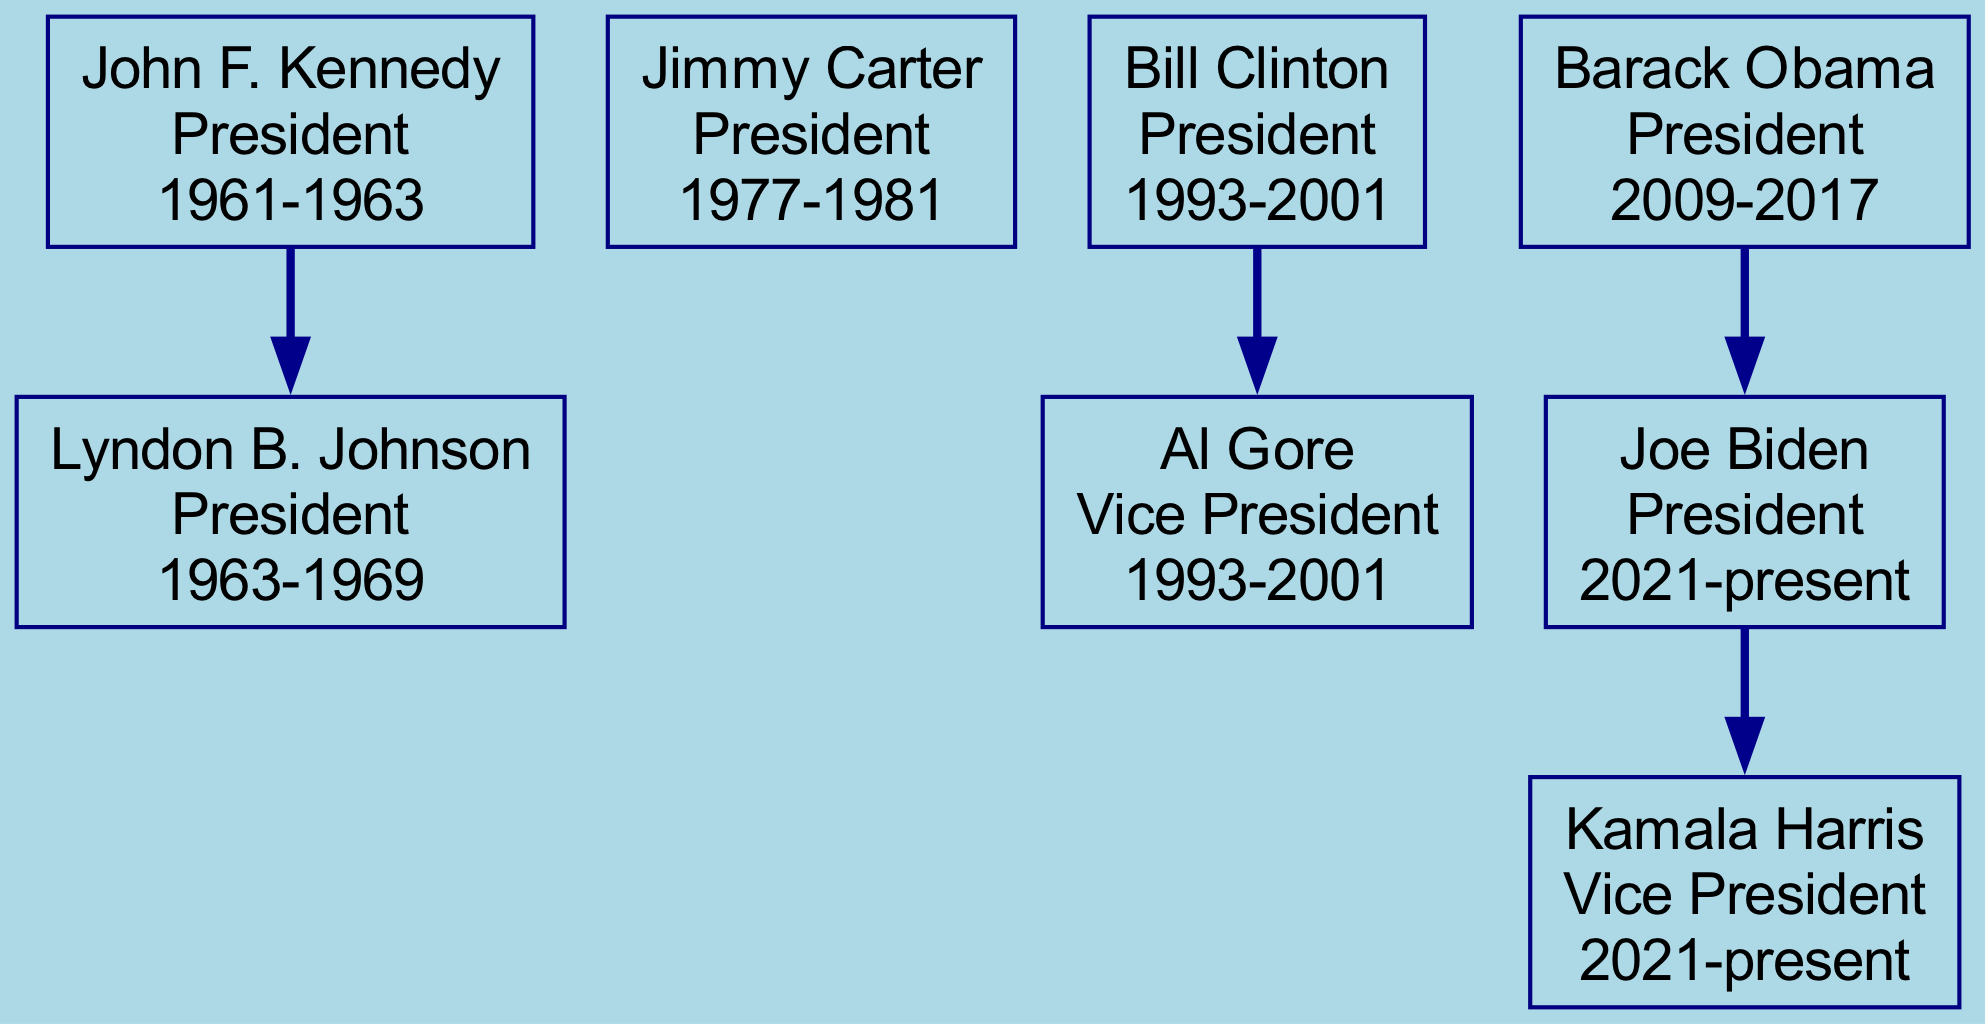What is the position of Joe Biden? Joe Biden is labeled as "President" in the diagram, which is explicitly marked next to his name.
Answer: President Who was Vice President under Bill Clinton? The diagram shows that Al Gore is listed as a child of Bill Clinton, indicating that he served as Vice President during Clinton's presidency.
Answer: Al Gore In what years did Barack Obama serve as President? The years next to Barack Obama's name in the diagram clearly state "2009-2017", indicating his term in office.
Answer: 2009-2017 How many Presidents are listed in the diagram? By counting the main nodes that represent Presidents—John F. Kennedy, Jimmy Carter, Bill Clinton, Barack Obama, and Joe Biden—the total comes to five Presidents.
Answer: 5 Which leader directly succeeded John F. Kennedy? The diagram shows a direct connection (edge) from John F. Kennedy to Lyndon B. Johnson, indicating that Johnson succeeded him.
Answer: Lyndon B. Johnson What is the relationship between Barack Obama and Joe Biden in the diagram? The diagram indicates that Joe Biden is a child of Barack Obama, which means Biden served as Vice President under Obama.
Answer: Vice President How many Vice Presidents are represented in the diagram? The diagram reveals that there are three distinct Vice Presidents: Al Gore, Joe Biden, and Kamala Harris.
Answer: 3 What position does Kamala Harris hold? Kamala Harris is explicitly labeled as "Vice President" in the diagram, which is shown next to her name.
Answer: Vice President Which President served from 1977 to 1981? The diagram clearly identifies Jimmy Carter as the individual who held the office of President during the years 1977-1981.
Answer: Jimmy Carter 